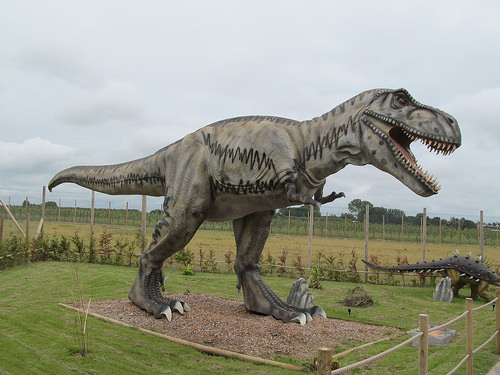<image>
Can you confirm if the dinosaur is on the ground? Yes. Looking at the image, I can see the dinosaur is positioned on top of the ground, with the ground providing support. 